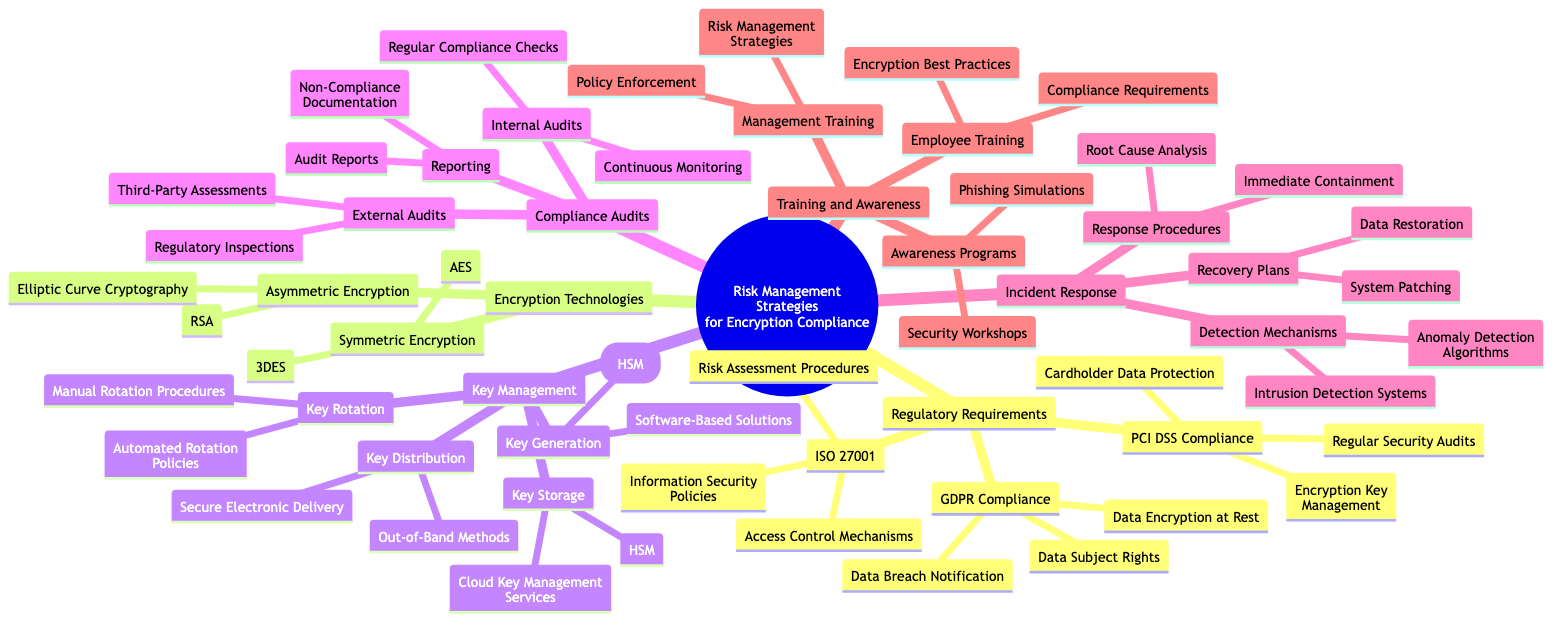What are the three regulatory requirements listed under GDPR Compliance? The diagram shows three requirements related to GDPR Compliance: "Data Subject Rights", "Data Breach Notification", and "Data Encryption at Rest". These are all key components associated with GDPR, thus representing the core focus within that section.
Answer: Data Subject Rights, Data Breach Notification, Data Encryption at Rest How many types of Encryption Technologies are mentioned in the diagram? The diagram lists two main types of Encryption Technologies: "Symmetric Encryption" and "Asymmetric Encryption". By counting these categories, we can determine the total number of types provided.
Answer: 2 What is one method listed under Key Generation? Within the Key Management section of the diagram, there are two methods under Key Generation: "Hardware Security Modules (HSM)" and "Software-Based Solutions". The user is asked to identify just one, and either of these is valid.
Answer: Hardware Security Modules (HSM) What does PCI DSS Compliance focus on regarding regular activities? In the PCI DSS Compliance section, one of the focuses is on "Regular Security Audits". This requirement emphasizes the importance of ongoing security measures to protect cardholder data compliance.
Answer: Regular Security Audits Which incident response procedure is aimed at immediate action? The diagram specifies "Immediate Containment" as a key response procedure in Incident Response. This term indicates a method intended for quick action to mitigate risks immediately following any detected incidents.
Answer: Immediate Containment What is one goal of Employee Training in the Training and Awareness section? Under the Training and Awareness section, one significant aspect of Employee Training is "Encryption Best Practices". This highlights the necessity for employees to be well-informed about optimal practices for encryption compliance.
Answer: Encryption Best Practices How many elements are listed under the Key Storage category? Key Storage features two elements in the diagram: "HSM" and "Cloud Key Management Services". By tallying these, the total number of elements in this category can be easily determined.
Answer: 2 What type of audits are performed externally? In the Compliance Audits section, the diagram indicates that "External Audits" consist of "Third-Party Assessments" and "Regulatory Inspections". For this question, identifying one type demonstrates understanding of external mechanisms available for compliance verification.
Answer: Third-Party Assessments Which Recovery Plan is related to restoring functionality? According to the Incident Response section, "Data Restoration" is a Recovery Plan aimed at bringing functionality back after an incident. This term refers directly to ensuring data is made available and systems are restored post-incident.
Answer: Data Restoration 